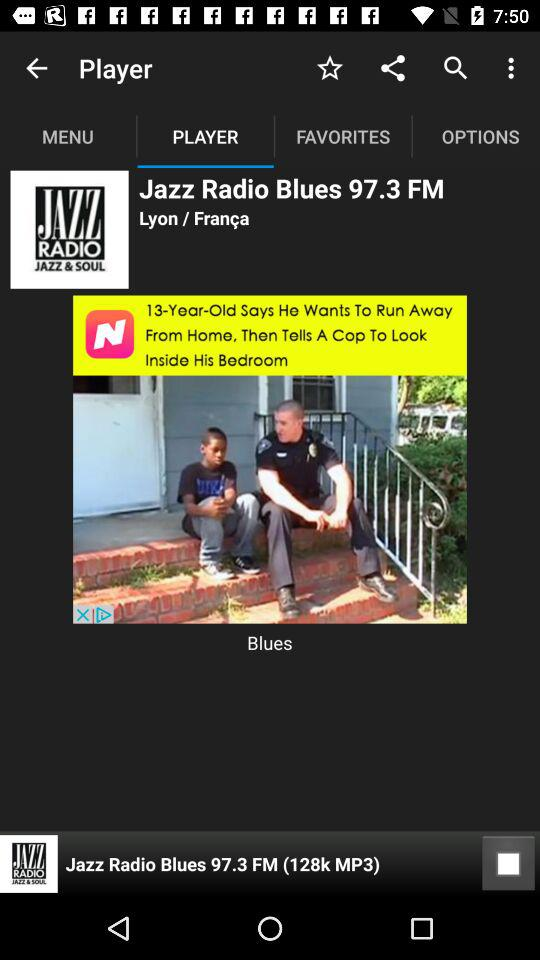What is the selected tab? The selected tab is "PLAYER". 